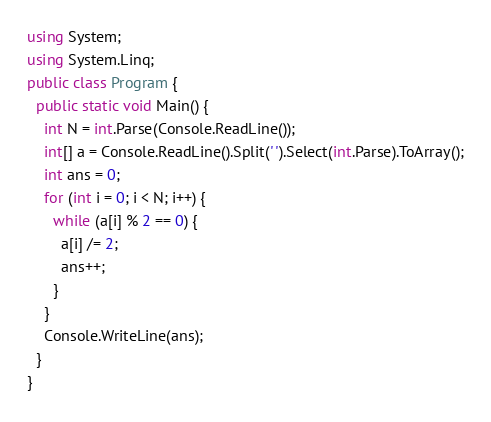Convert code to text. <code><loc_0><loc_0><loc_500><loc_500><_C#_>using System;
using System.Linq;
public class Program {
  public static void Main() {
    int N = int.Parse(Console.ReadLine());
    int[] a = Console.ReadLine().Split(' ').Select(int.Parse).ToArray();
    int ans = 0;
    for (int i = 0; i < N; i++) {
      while (a[i] % 2 == 0) {
        a[i] /= 2;
        ans++;
      }
    }
    Console.WriteLine(ans);
  }
}
</code> 